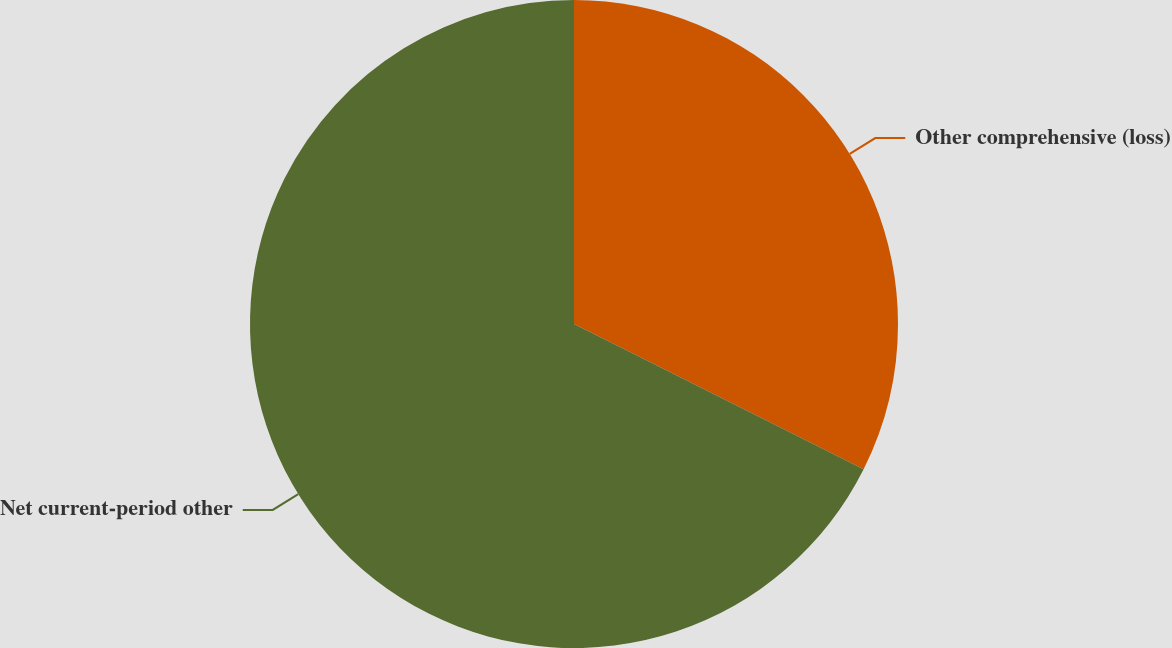Convert chart to OTSL. <chart><loc_0><loc_0><loc_500><loc_500><pie_chart><fcel>Other comprehensive (loss)<fcel>Net current-period other<nl><fcel>32.4%<fcel>67.6%<nl></chart> 